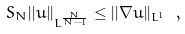Convert formula to latex. <formula><loc_0><loc_0><loc_500><loc_500>S _ { N } | | u | | _ { L ^ { \frac { N } { N - 1 } } } \leq | | \nabla u | | _ { L ^ { 1 } } \ ,</formula> 